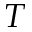Convert formula to latex. <formula><loc_0><loc_0><loc_500><loc_500>T</formula> 